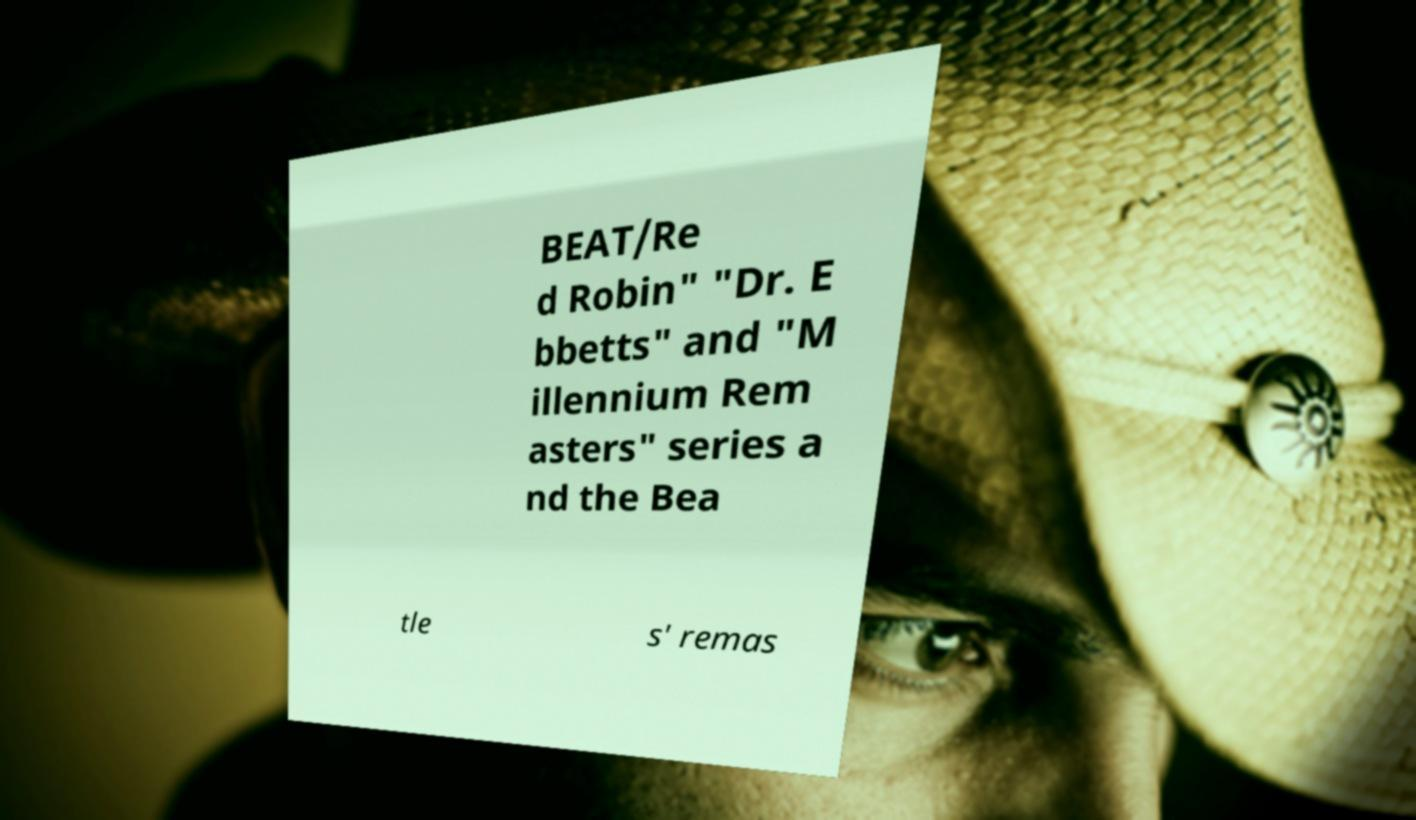For documentation purposes, I need the text within this image transcribed. Could you provide that? BEAT/Re d Robin" "Dr. E bbetts" and "M illennium Rem asters" series a nd the Bea tle s' remas 